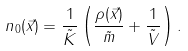Convert formula to latex. <formula><loc_0><loc_0><loc_500><loc_500>n _ { 0 } ( \vec { x } ) = \frac { 1 } { \tilde { K } } \left ( \frac { \rho ( \vec { x } ) } { \tilde { m } } + \frac { 1 } { \tilde { V } } \right ) .</formula> 